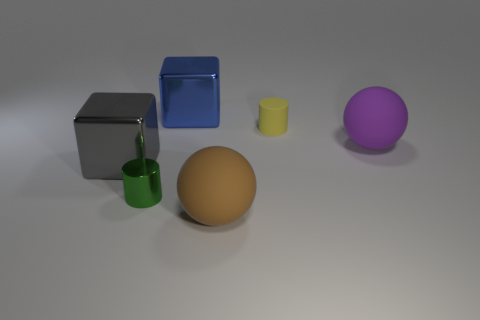Add 2 big spheres. How many objects exist? 8 Subtract all balls. How many objects are left? 4 Subtract 0 red blocks. How many objects are left? 6 Subtract all tiny gray matte things. Subtract all tiny matte cylinders. How many objects are left? 5 Add 6 brown things. How many brown things are left? 7 Add 3 small purple cylinders. How many small purple cylinders exist? 3 